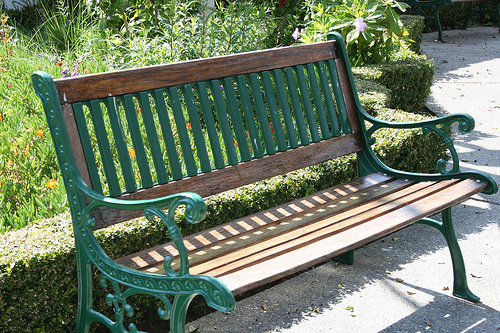How many benches are seen? There is one bench visible in the image. It features a combination of a cast iron frame with intricate patterns and wooden slats for seating and back support, situated amidst a garden setting which adds to its charm. 